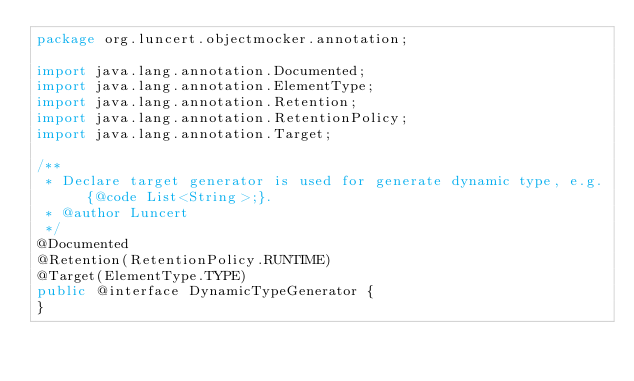Convert code to text. <code><loc_0><loc_0><loc_500><loc_500><_Java_>package org.luncert.objectmocker.annotation;

import java.lang.annotation.Documented;
import java.lang.annotation.ElementType;
import java.lang.annotation.Retention;
import java.lang.annotation.RetentionPolicy;
import java.lang.annotation.Target;

/**
 * Declare target generator is used for generate dynamic type, e.g. {@code List<String>;}.
 * @author Luncert
 */
@Documented
@Retention(RetentionPolicy.RUNTIME)
@Target(ElementType.TYPE)
public @interface DynamicTypeGenerator {
}
</code> 